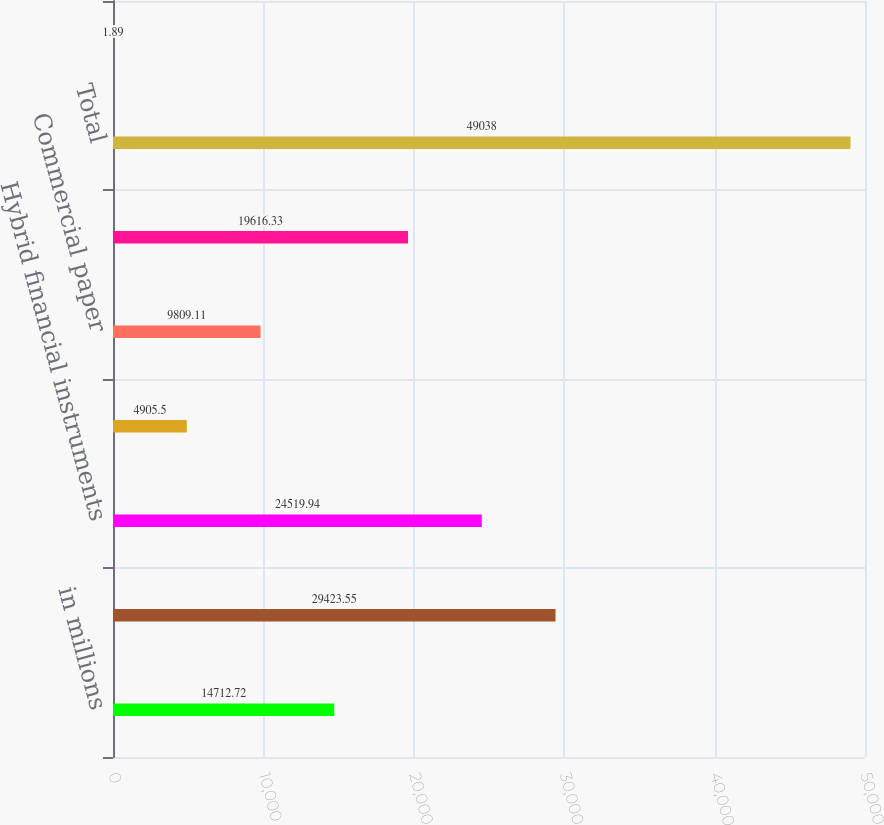Convert chart to OTSL. <chart><loc_0><loc_0><loc_500><loc_500><bar_chart><fcel>in millions<fcel>Current portion of unsecured<fcel>Hybrid financial instruments<fcel>Promissory notes<fcel>Commercial paper<fcel>Other short-term borrowings<fcel>Total<fcel>Weighted average interest rate<nl><fcel>14712.7<fcel>29423.5<fcel>24519.9<fcel>4905.5<fcel>9809.11<fcel>19616.3<fcel>49038<fcel>1.89<nl></chart> 